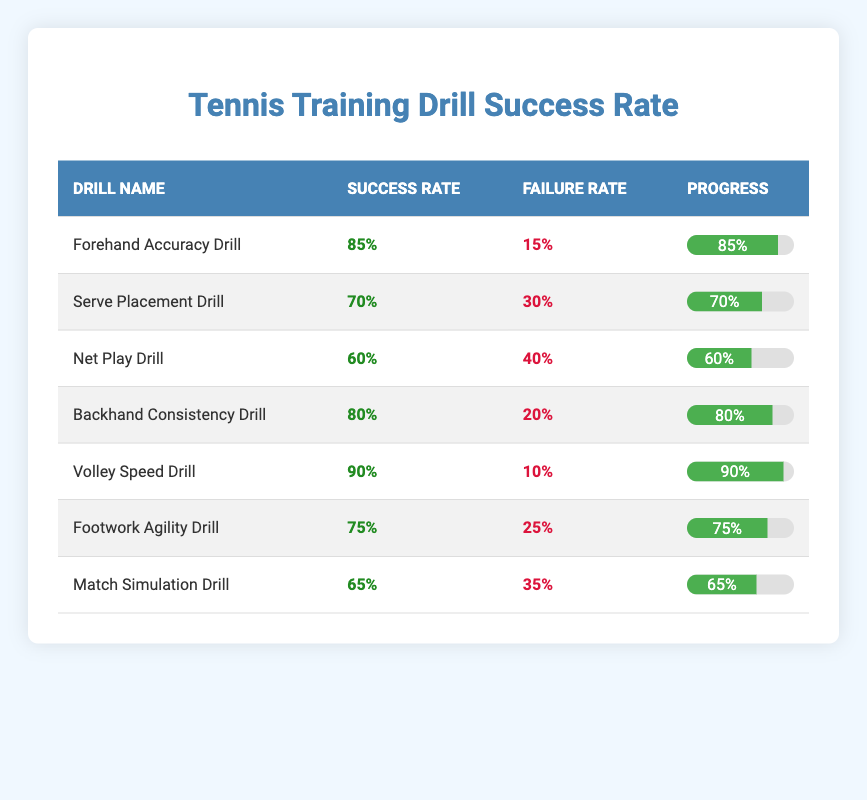What is the success rate of the Volley Speed Drill? The Volley Speed Drill has a success rate of 90%, as indicated in the table under the Success Rate column associated with that drill.
Answer: 90% Which drill has the lowest success rate? The Net Play Drill has the lowest success rate at 60%, as seen in the Success Rate column of the table.
Answer: 60% What is the difference in success rates between the Forehand Accuracy Drill and the Serve Placement Drill? The success rate of the Forehand Accuracy Drill is 85% and the Serve Placement Drill is 70%. The difference is 85% - 70% = 15%.
Answer: 15% Is the success rate of the Backhand Consistency Drill higher than that of the Match Simulation Drill? The Backhand Consistency Drill has a success rate of 80%, while the Match Simulation Drill has a success rate of 65%. Therefore, the Backhand Consistency Drill's success rate is indeed higher than that of the Match Simulation Drill.
Answer: Yes What is the average success rate of all the drills combined? To find the average success rate, sum all the success rates (85 + 70 + 60 + 80 + 90 + 75 + 65 = 525), and divide by the number of drills (7). The average is 525 / 7 = 75%.
Answer: 75% What percentage of drills have a success rate of 75% or higher? The drills with a success rate of 75% or higher are the Forehand Accuracy Drill, Backhand Consistency Drill, Volley Speed Drill, and Footwork Agility Drill. That's 4 out of 7 drills, which is approximately 57.14%.
Answer: Approximately 57% Are there any drills with a success rate below 70%? Yes, the Net Play Drill (60%) and the Match Simulation Drill (65%) both have success rates below 70%.
Answer: Yes What is the combined number of unsuccessful training drills? The total number of unsuccessful drills can be calculated by adding the unsuccessful counts from the table (15 + 30 + 40 + 20 + 10 + 25 + 35 = 175).
Answer: 175 